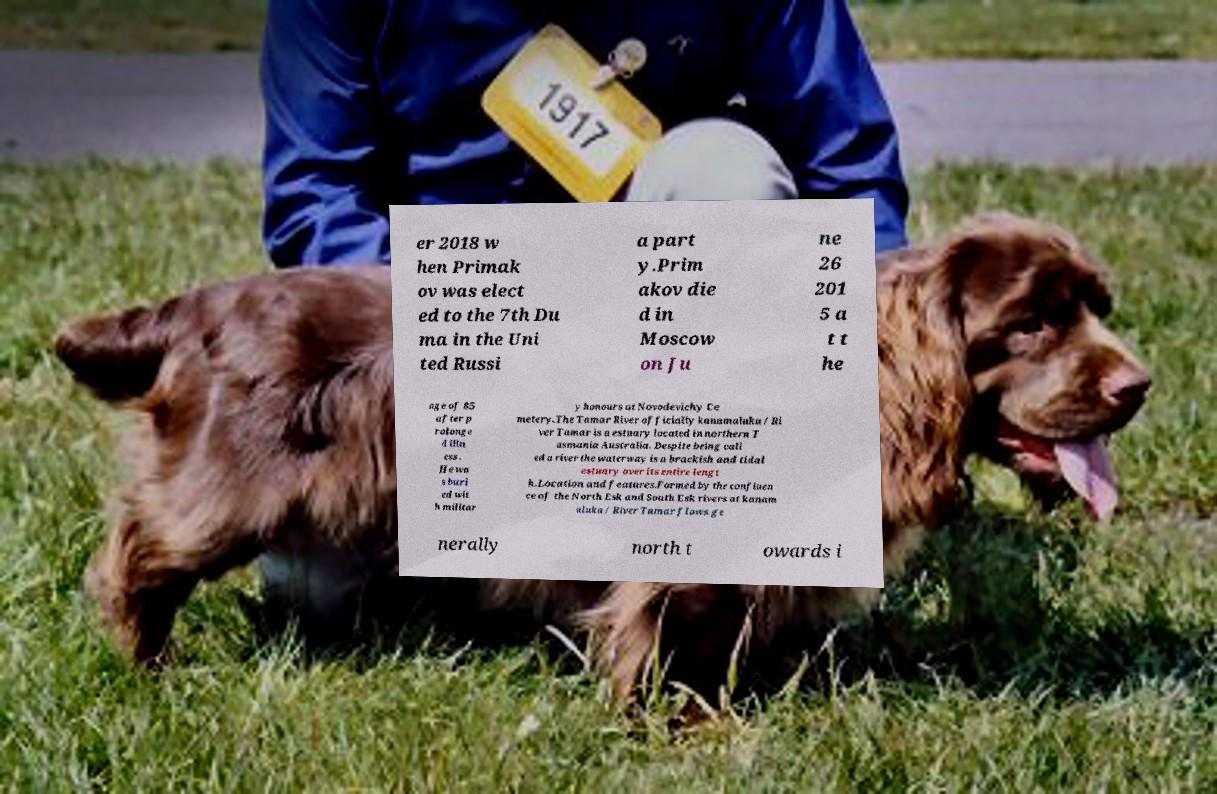For documentation purposes, I need the text within this image transcribed. Could you provide that? er 2018 w hen Primak ov was elect ed to the 7th Du ma in the Uni ted Russi a part y.Prim akov die d in Moscow on Ju ne 26 201 5 a t t he age of 85 after p rolonge d illn ess . He wa s buri ed wit h militar y honours at Novodevichy Ce metery.The Tamar River officially kanamaluka / Ri ver Tamar is a estuary located in northern T asmania Australia. Despite being call ed a river the waterway is a brackish and tidal estuary over its entire lengt h.Location and features.Formed by the confluen ce of the North Esk and South Esk rivers at kanam aluka / River Tamar flows ge nerally north t owards i 